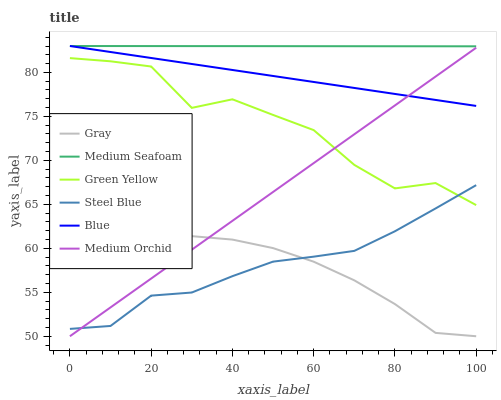Does Gray have the minimum area under the curve?
Answer yes or no. Yes. Does Medium Seafoam have the maximum area under the curve?
Answer yes or no. Yes. Does Medium Orchid have the minimum area under the curve?
Answer yes or no. No. Does Medium Orchid have the maximum area under the curve?
Answer yes or no. No. Is Medium Seafoam the smoothest?
Answer yes or no. Yes. Is Green Yellow the roughest?
Answer yes or no. Yes. Is Gray the smoothest?
Answer yes or no. No. Is Gray the roughest?
Answer yes or no. No. Does Gray have the lowest value?
Answer yes or no. Yes. Does Steel Blue have the lowest value?
Answer yes or no. No. Does Medium Seafoam have the highest value?
Answer yes or no. Yes. Does Medium Orchid have the highest value?
Answer yes or no. No. Is Medium Orchid less than Medium Seafoam?
Answer yes or no. Yes. Is Blue greater than Gray?
Answer yes or no. Yes. Does Medium Orchid intersect Steel Blue?
Answer yes or no. Yes. Is Medium Orchid less than Steel Blue?
Answer yes or no. No. Is Medium Orchid greater than Steel Blue?
Answer yes or no. No. Does Medium Orchid intersect Medium Seafoam?
Answer yes or no. No. 